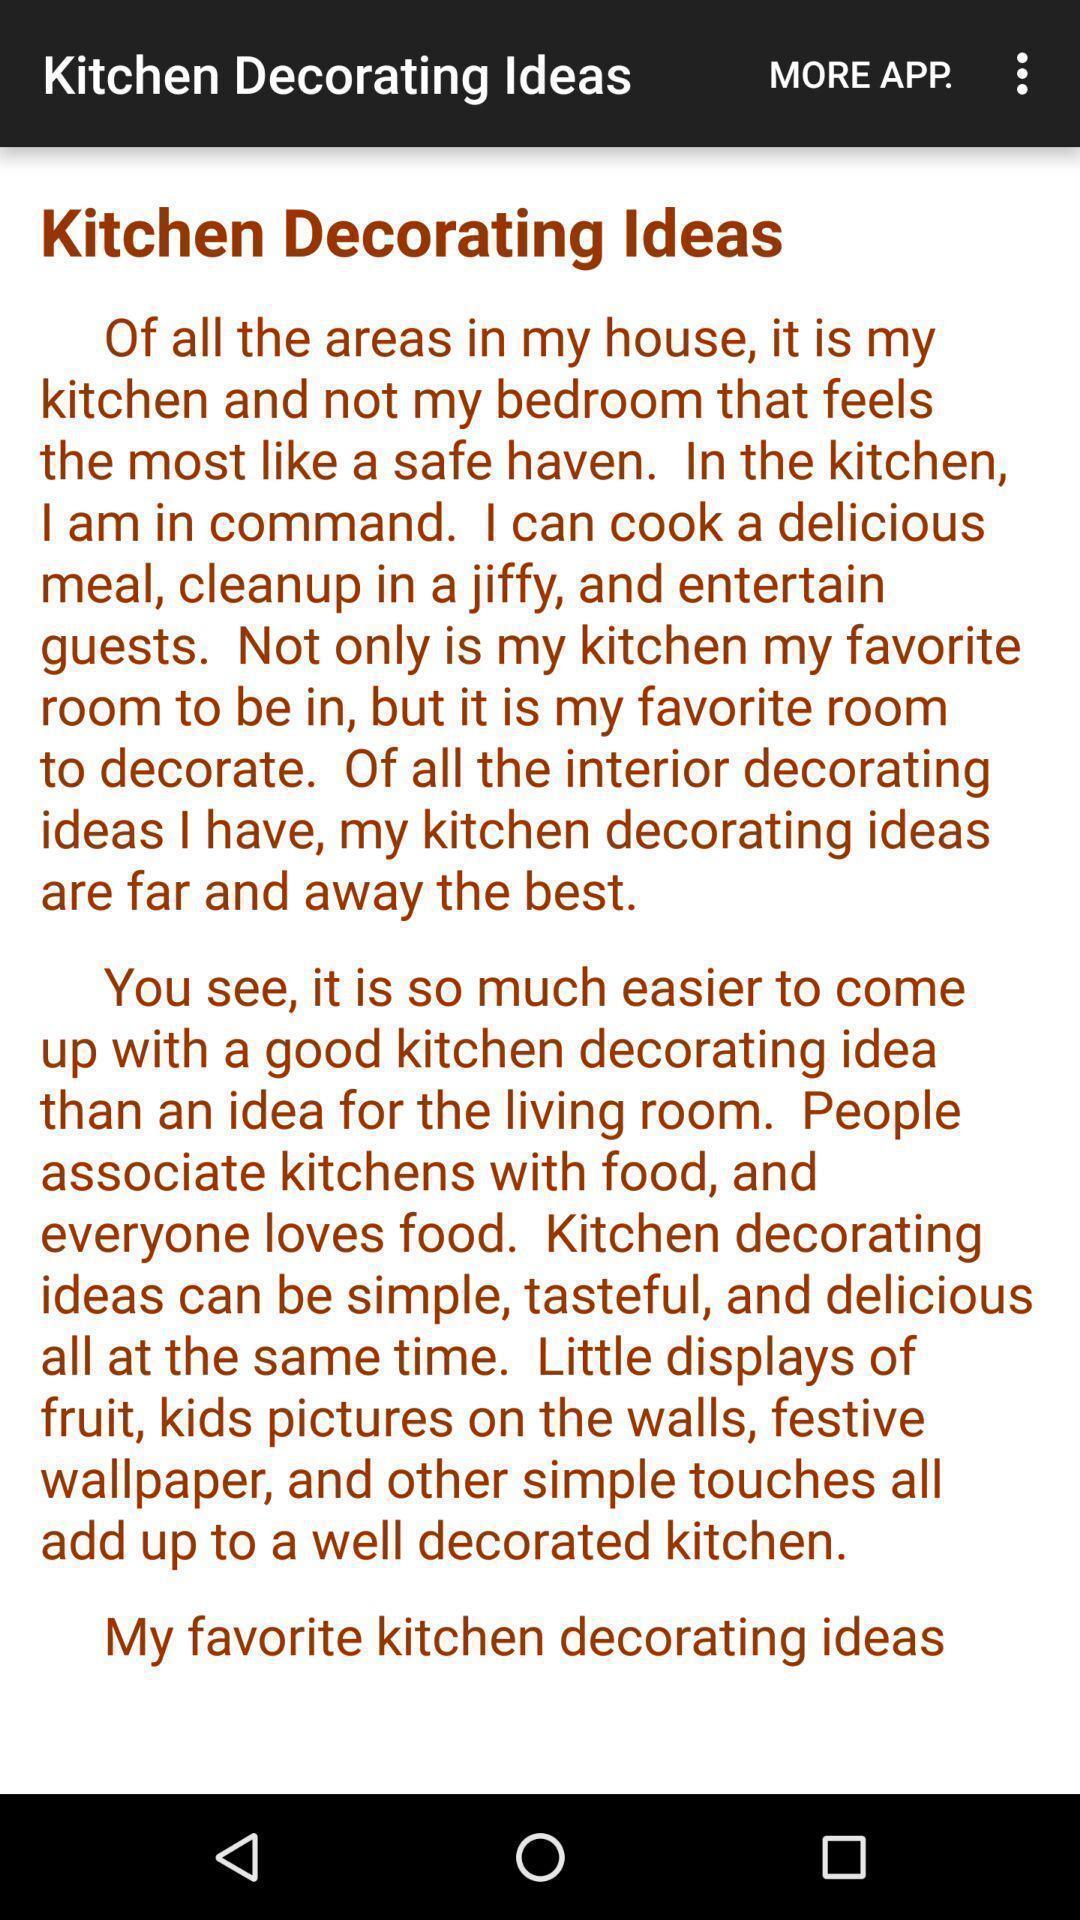Explain what's happening in this screen capture. Page displaying the kitchen decorating ideas. 